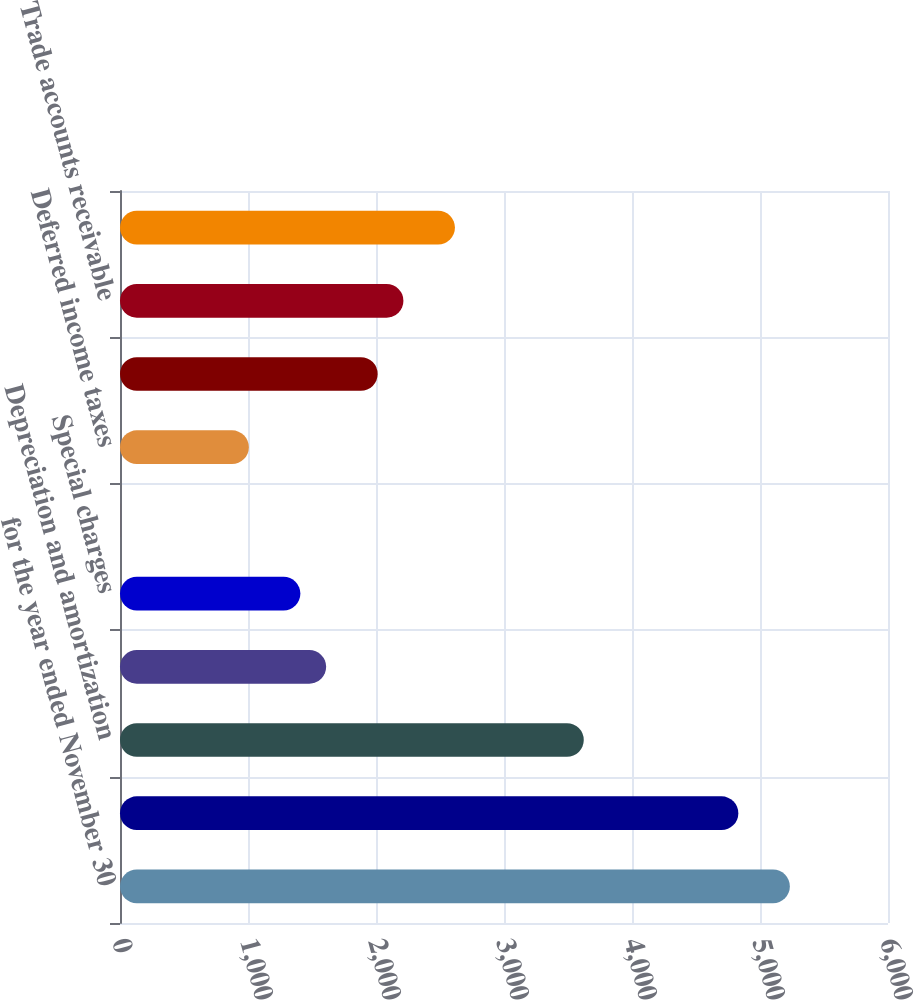Convert chart. <chart><loc_0><loc_0><loc_500><loc_500><bar_chart><fcel>for the year ended November 30<fcel>Net income<fcel>Depreciation and amortization<fcel>Stock-based compensation<fcel>Special charges<fcel>Loss on sale of assets<fcel>Deferred income taxes<fcel>Income from unconsolidated<fcel>Trade accounts receivable<fcel>Inventories<nl><fcel>5233.32<fcel>4830.78<fcel>3623.16<fcel>1610.46<fcel>1409.19<fcel>0.3<fcel>1006.65<fcel>2013<fcel>2214.27<fcel>2616.81<nl></chart> 